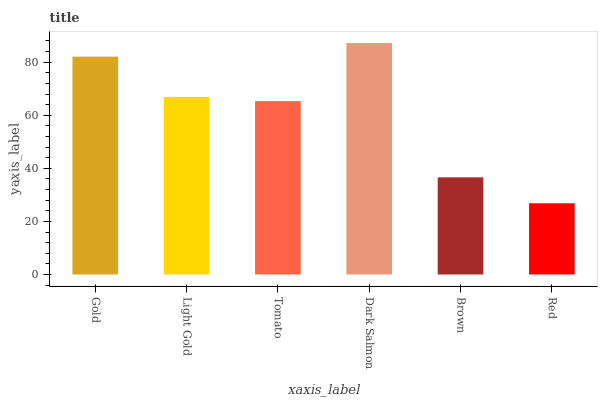Is Light Gold the minimum?
Answer yes or no. No. Is Light Gold the maximum?
Answer yes or no. No. Is Gold greater than Light Gold?
Answer yes or no. Yes. Is Light Gold less than Gold?
Answer yes or no. Yes. Is Light Gold greater than Gold?
Answer yes or no. No. Is Gold less than Light Gold?
Answer yes or no. No. Is Light Gold the high median?
Answer yes or no. Yes. Is Tomato the low median?
Answer yes or no. Yes. Is Dark Salmon the high median?
Answer yes or no. No. Is Red the low median?
Answer yes or no. No. 